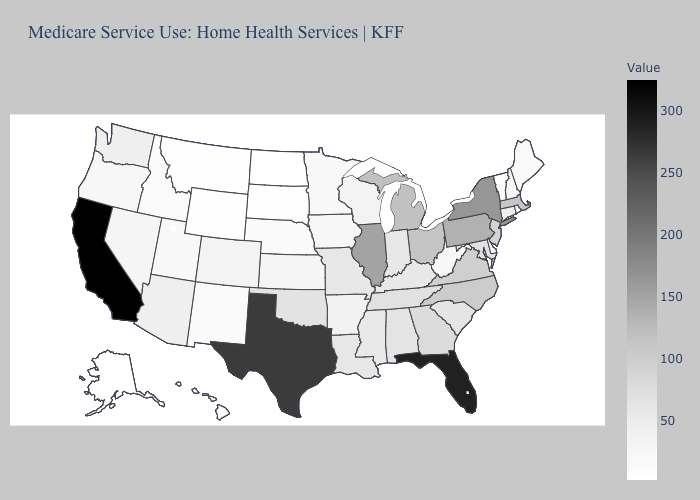Among the states that border Michigan , which have the lowest value?
Concise answer only. Wisconsin. Which states hav the highest value in the MidWest?
Short answer required. Illinois. Is the legend a continuous bar?
Write a very short answer. Yes. Is the legend a continuous bar?
Write a very short answer. Yes. Does North Dakota have the highest value in the MidWest?
Short answer required. No. Among the states that border Michigan , does Indiana have the lowest value?
Answer briefly. No. Does Missouri have the lowest value in the MidWest?
Quick response, please. No. Which states have the highest value in the USA?
Concise answer only. California. 